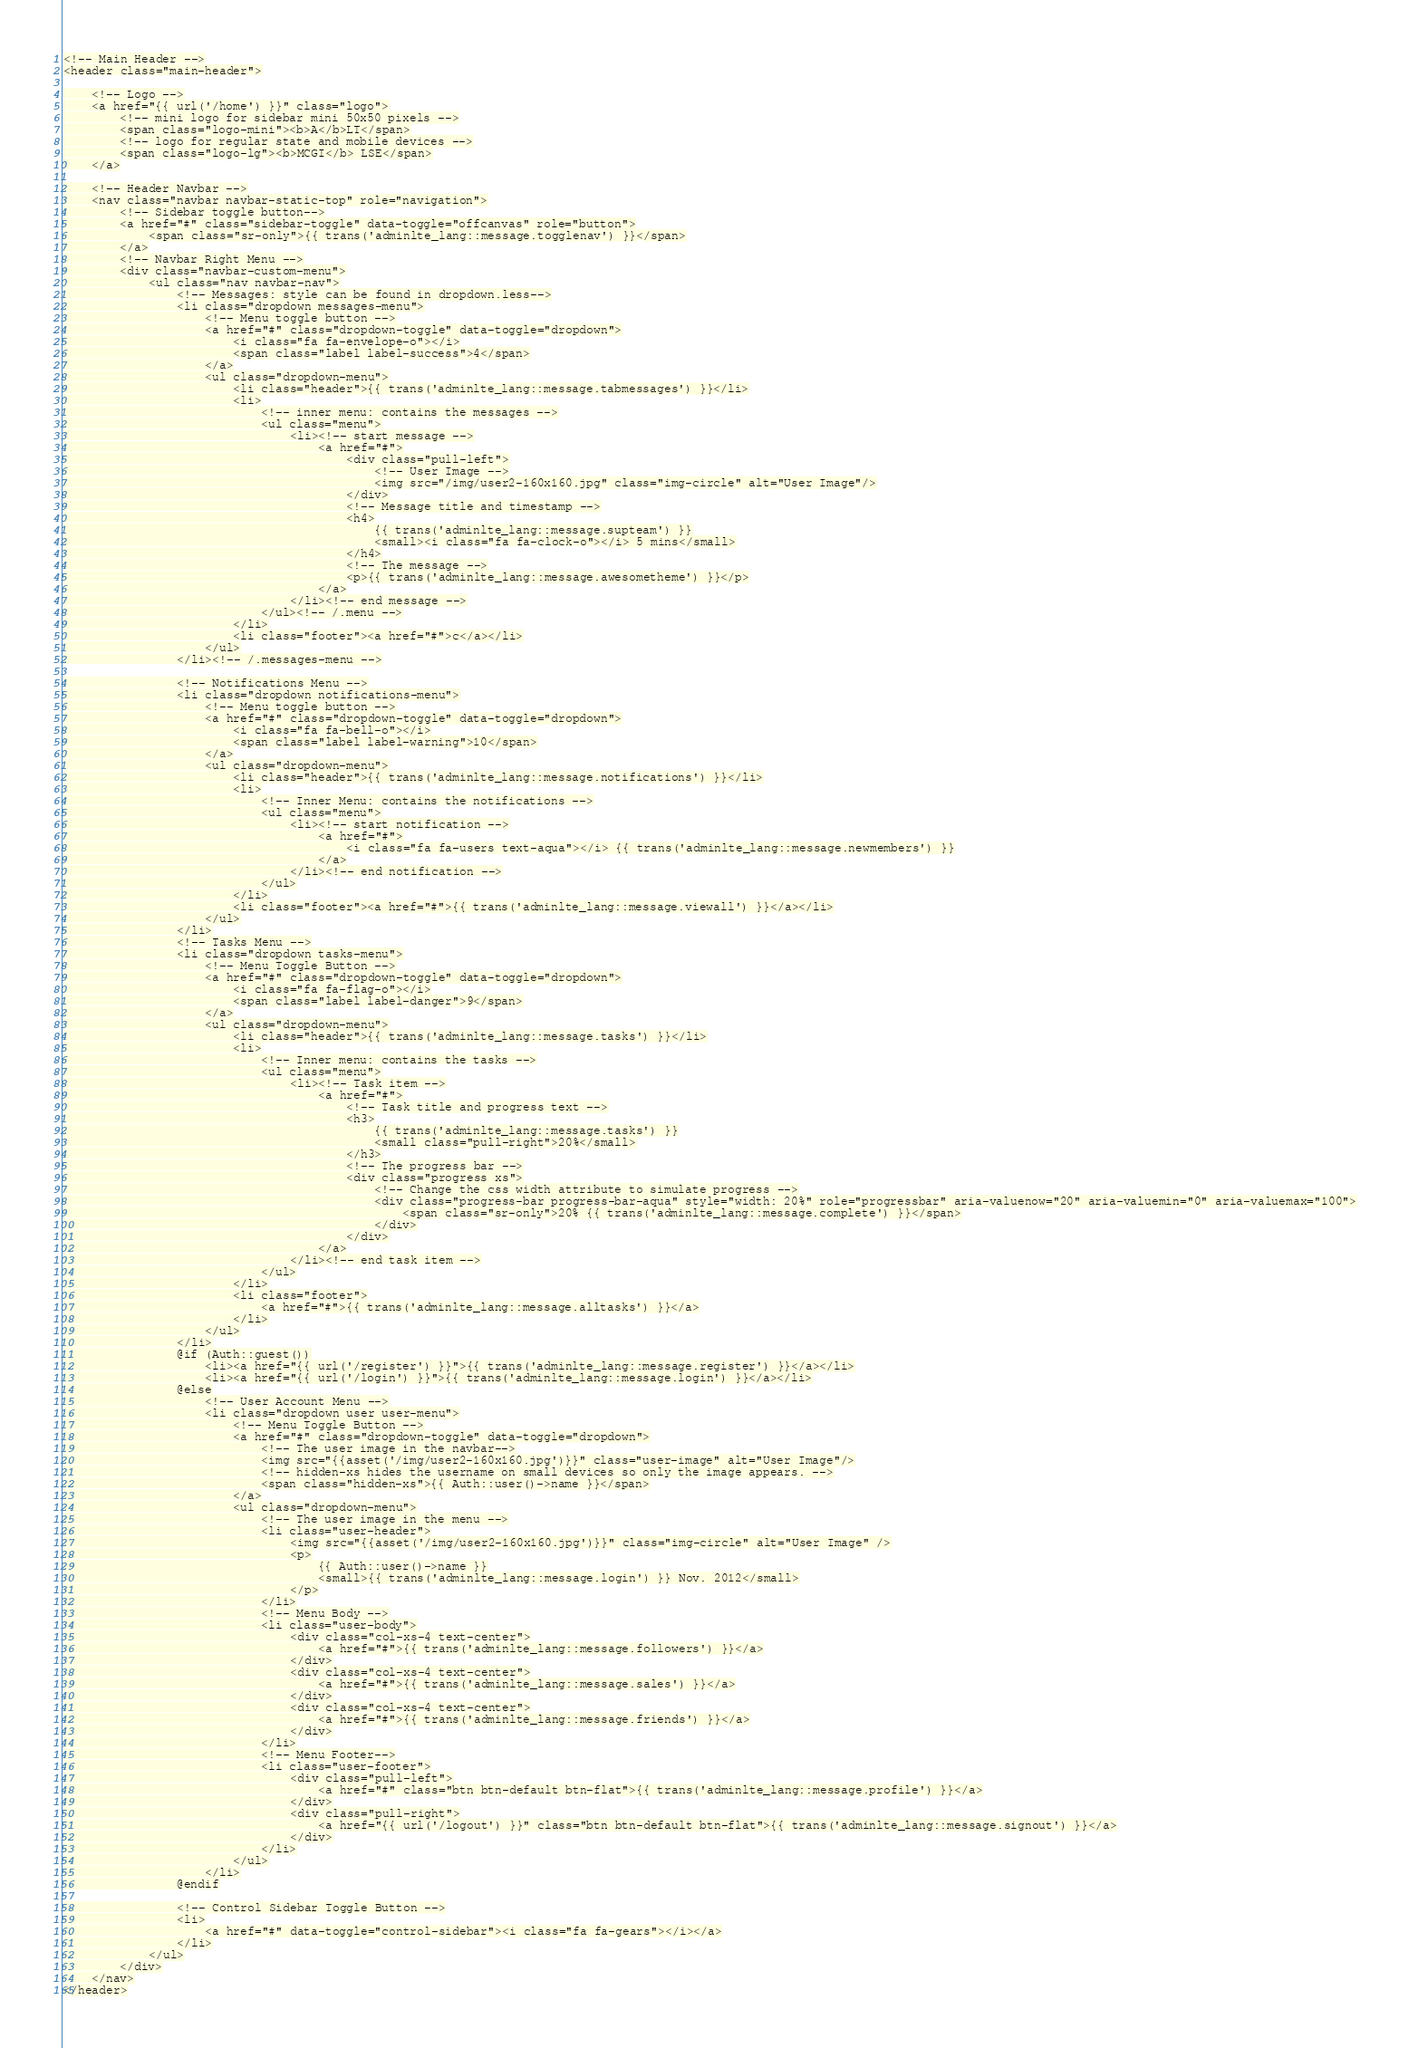<code> <loc_0><loc_0><loc_500><loc_500><_PHP_><!-- Main Header -->
<header class="main-header">

    <!-- Logo -->
    <a href="{{ url('/home') }}" class="logo">
        <!-- mini logo for sidebar mini 50x50 pixels -->
        <span class="logo-mini"><b>A</b>LT</span>
        <!-- logo for regular state and mobile devices -->
        <span class="logo-lg"><b>MCGI</b> LSE</span>
    </a>

    <!-- Header Navbar -->
    <nav class="navbar navbar-static-top" role="navigation">
        <!-- Sidebar toggle button-->
        <a href="#" class="sidebar-toggle" data-toggle="offcanvas" role="button">
            <span class="sr-only">{{ trans('adminlte_lang::message.togglenav') }}</span>
        </a>
        <!-- Navbar Right Menu -->
        <div class="navbar-custom-menu">
            <ul class="nav navbar-nav">
                <!-- Messages: style can be found in dropdown.less-->
                <li class="dropdown messages-menu">
                    <!-- Menu toggle button -->
                    <a href="#" class="dropdown-toggle" data-toggle="dropdown">
                        <i class="fa fa-envelope-o"></i>
                        <span class="label label-success">4</span>
                    </a>
                    <ul class="dropdown-menu">
                        <li class="header">{{ trans('adminlte_lang::message.tabmessages') }}</li>
                        <li>
                            <!-- inner menu: contains the messages -->
                            <ul class="menu">
                                <li><!-- start message -->
                                    <a href="#">
                                        <div class="pull-left">
                                            <!-- User Image -->
                                            <img src="/img/user2-160x160.jpg" class="img-circle" alt="User Image"/>
                                        </div>
                                        <!-- Message title and timestamp -->
                                        <h4>
                                            {{ trans('adminlte_lang::message.supteam') }}
                                            <small><i class="fa fa-clock-o"></i> 5 mins</small>
                                        </h4>
                                        <!-- The message -->
                                        <p>{{ trans('adminlte_lang::message.awesometheme') }}</p>
                                    </a>
                                </li><!-- end message -->
                            </ul><!-- /.menu -->
                        </li>
                        <li class="footer"><a href="#">c</a></li>
                    </ul>
                </li><!-- /.messages-menu -->

                <!-- Notifications Menu -->
                <li class="dropdown notifications-menu">
                    <!-- Menu toggle button -->
                    <a href="#" class="dropdown-toggle" data-toggle="dropdown">
                        <i class="fa fa-bell-o"></i>
                        <span class="label label-warning">10</span>
                    </a>
                    <ul class="dropdown-menu">
                        <li class="header">{{ trans('adminlte_lang::message.notifications') }}</li>
                        <li>
                            <!-- Inner Menu: contains the notifications -->
                            <ul class="menu">
                                <li><!-- start notification -->
                                    <a href="#">
                                        <i class="fa fa-users text-aqua"></i> {{ trans('adminlte_lang::message.newmembers') }}
                                    </a>
                                </li><!-- end notification -->
                            </ul>
                        </li>
                        <li class="footer"><a href="#">{{ trans('adminlte_lang::message.viewall') }}</a></li>
                    </ul>
                </li>
                <!-- Tasks Menu -->
                <li class="dropdown tasks-menu">
                    <!-- Menu Toggle Button -->
                    <a href="#" class="dropdown-toggle" data-toggle="dropdown">
                        <i class="fa fa-flag-o"></i>
                        <span class="label label-danger">9</span>
                    </a>
                    <ul class="dropdown-menu">
                        <li class="header">{{ trans('adminlte_lang::message.tasks') }}</li>
                        <li>
                            <!-- Inner menu: contains the tasks -->
                            <ul class="menu">
                                <li><!-- Task item -->
                                    <a href="#">
                                        <!-- Task title and progress text -->
                                        <h3>
                                            {{ trans('adminlte_lang::message.tasks') }}
                                            <small class="pull-right">20%</small>
                                        </h3>
                                        <!-- The progress bar -->
                                        <div class="progress xs">
                                            <!-- Change the css width attribute to simulate progress -->
                                            <div class="progress-bar progress-bar-aqua" style="width: 20%" role="progressbar" aria-valuenow="20" aria-valuemin="0" aria-valuemax="100">
                                                <span class="sr-only">20% {{ trans('adminlte_lang::message.complete') }}</span>
                                            </div>
                                        </div>
                                    </a>
                                </li><!-- end task item -->
                            </ul>
                        </li>
                        <li class="footer">
                            <a href="#">{{ trans('adminlte_lang::message.alltasks') }}</a>
                        </li>
                    </ul>
                </li>
                @if (Auth::guest())
                    <li><a href="{{ url('/register') }}">{{ trans('adminlte_lang::message.register') }}</a></li>
                    <li><a href="{{ url('/login') }}">{{ trans('adminlte_lang::message.login') }}</a></li>
                @else
                    <!-- User Account Menu -->
                    <li class="dropdown user user-menu">
                        <!-- Menu Toggle Button -->
                        <a href="#" class="dropdown-toggle" data-toggle="dropdown">
                            <!-- The user image in the navbar-->
                            <img src="{{asset('/img/user2-160x160.jpg')}}" class="user-image" alt="User Image"/>
                            <!-- hidden-xs hides the username on small devices so only the image appears. -->
                            <span class="hidden-xs">{{ Auth::user()->name }}</span>
                        </a>
                        <ul class="dropdown-menu">
                            <!-- The user image in the menu -->
                            <li class="user-header">
                                <img src="{{asset('/img/user2-160x160.jpg')}}" class="img-circle" alt="User Image" />
                                <p>
                                    {{ Auth::user()->name }}
                                    <small>{{ trans('adminlte_lang::message.login') }} Nov. 2012</small>
                                </p>
                            </li>
                            <!-- Menu Body -->
                            <li class="user-body">
                                <div class="col-xs-4 text-center">
                                    <a href="#">{{ trans('adminlte_lang::message.followers') }}</a>
                                </div>
                                <div class="col-xs-4 text-center">
                                    <a href="#">{{ trans('adminlte_lang::message.sales') }}</a>
                                </div>
                                <div class="col-xs-4 text-center">
                                    <a href="#">{{ trans('adminlte_lang::message.friends') }}</a>
                                </div>
                            </li>
                            <!-- Menu Footer-->
                            <li class="user-footer">
                                <div class="pull-left">
                                    <a href="#" class="btn btn-default btn-flat">{{ trans('adminlte_lang::message.profile') }}</a>
                                </div>
                                <div class="pull-right">
                                    <a href="{{ url('/logout') }}" class="btn btn-default btn-flat">{{ trans('adminlte_lang::message.signout') }}</a>
                                </div>
                            </li>
                        </ul>
                    </li>
                @endif

                <!-- Control Sidebar Toggle Button -->
                <li>
                    <a href="#" data-toggle="control-sidebar"><i class="fa fa-gears"></i></a>
                </li>
            </ul>
        </div>
    </nav>
</header>
</code> 